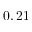Convert formula to latex. <formula><loc_0><loc_0><loc_500><loc_500>0 , 2 1</formula> 